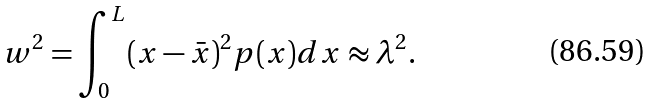<formula> <loc_0><loc_0><loc_500><loc_500>w ^ { 2 } = \int _ { 0 } ^ { L } ( x - \bar { x } ) ^ { 2 } p ( x ) d x \approx \lambda ^ { 2 } .</formula> 